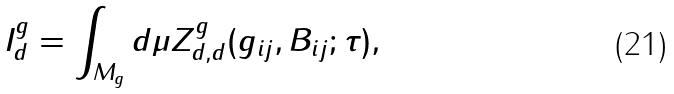<formula> <loc_0><loc_0><loc_500><loc_500>I _ { d } ^ { g } = \int _ { M _ { g } } d \mu Z _ { d , d } ^ { g } ( g _ { i j } , B _ { i j } ; \tau ) ,</formula> 